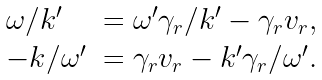<formula> <loc_0><loc_0><loc_500><loc_500>\begin{array} { l l } \omega / k ^ { \prime } & = \omega ^ { \prime } \gamma _ { r } / k ^ { \prime } - \gamma _ { r } v _ { r } , \\ - k / \omega ^ { \prime } & = \gamma _ { r } v _ { r } - k ^ { \prime } \gamma _ { r } / \omega ^ { \prime } . \end{array}</formula> 